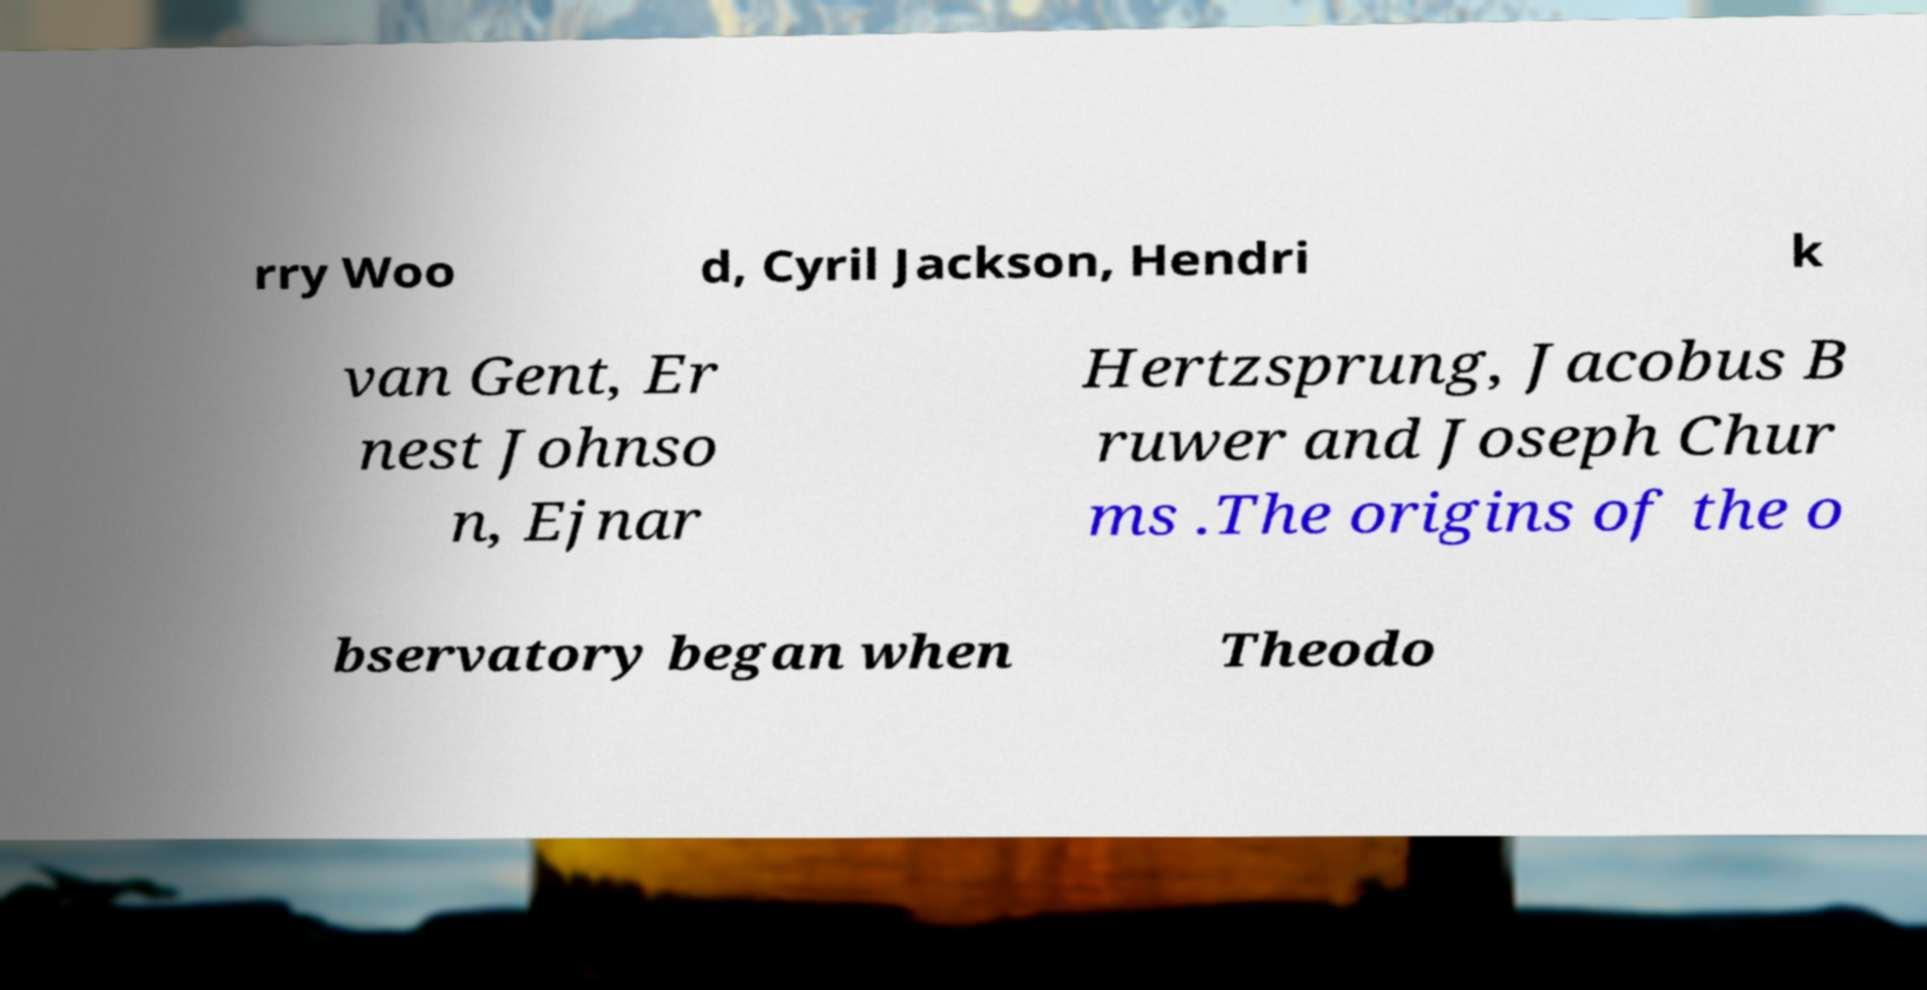For documentation purposes, I need the text within this image transcribed. Could you provide that? rry Woo d, Cyril Jackson, Hendri k van Gent, Er nest Johnso n, Ejnar Hertzsprung, Jacobus B ruwer and Joseph Chur ms .The origins of the o bservatory began when Theodo 